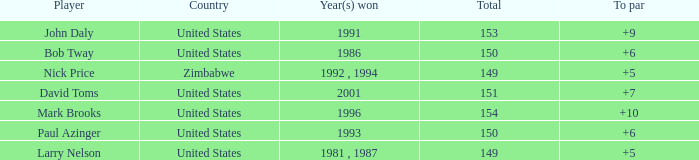What is the total for 1986 with a to par higher than 6? 0.0. 